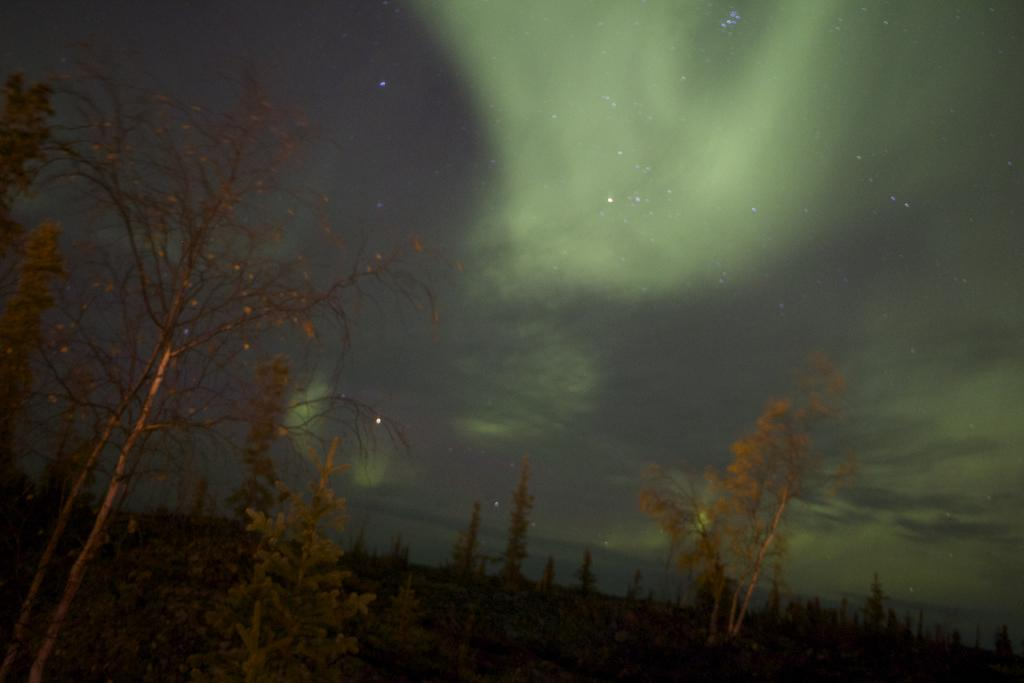What is located in the center of the image? There are trees in the center of the image. What is visible at the top of the image? The sky is visible at the top of the image. How many trucks are parked near the trees in the image? There are no trucks present in the image; it only features trees and the sky. What type of pest can be seen crawling on the leaves of the trees in the image? There is no pest visible on the trees in the image; only the trees and the sky are present. 